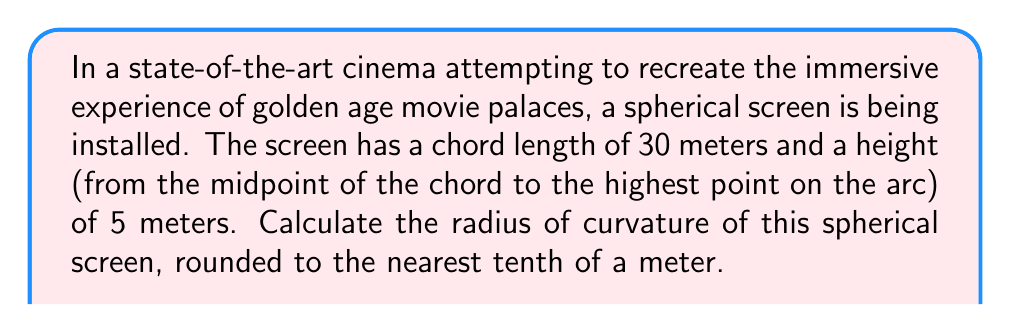Solve this math problem. Let's approach this step-by-step using concepts from spherical geometry:

1) In a sphere, we can use the equation relating the radius $r$, the chord length $c$, and the height $h$:

   $$r^2 = \frac{c^2}{4} + (r-h)^2$$

2) We're given that $c = 30$ meters and $h = 5$ meters. Let's substitute these values:

   $$r^2 = \frac{30^2}{4} + (r-5)^2$$

3) Simplify:

   $$r^2 = 225 + (r^2 - 10r + 25)$$

4) Combine like terms:

   $$2r^2 - 10r - 200 = 0$$

5) This is a quadratic equation. We can solve it using the quadratic formula:

   $$r = \frac{-b \pm \sqrt{b^2 - 4ac}}{2a}$$

   where $a=2$, $b=-10$, and $c=-200$

6) Substituting these values:

   $$r = \frac{10 \pm \sqrt{100 + 1600}}{4} = \frac{10 \pm \sqrt{1700}}{4}$$

7) Simplify:

   $$r = \frac{10 \pm 41.23}{4}$$

8) This gives us two solutions:

   $$r_1 = \frac{51.23}{4} = 12.81 \text{ meters}$$
   $$r_2 = \frac{-31.23}{4} = -7.81 \text{ meters}$$

9) Since we're dealing with a physical screen, we can discard the negative solution.

10) Rounding to the nearest tenth:

    $$r \approx 12.8 \text{ meters}$$
Answer: 12.8 meters 